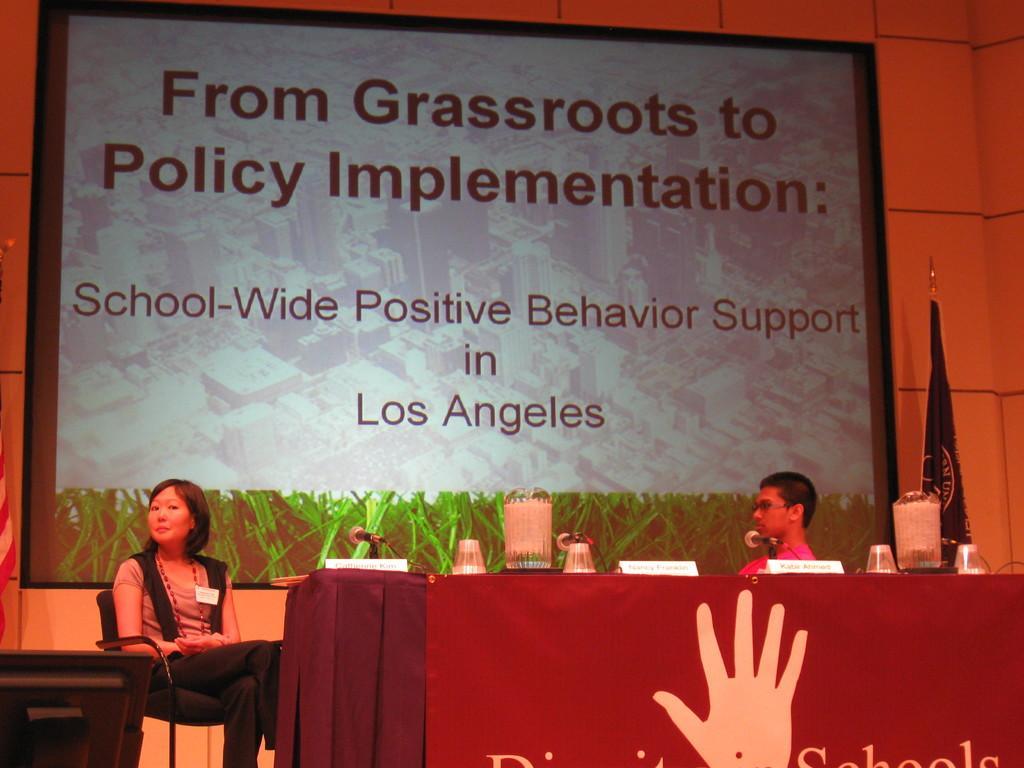Please provide a concise description of this image. In this image, few peoples are sat on the chair. There is a table, some cloth and some items are placed on it. On right side, we can see flag and wall. In the middle, there is a screen. On left side, we can see some monitor. 